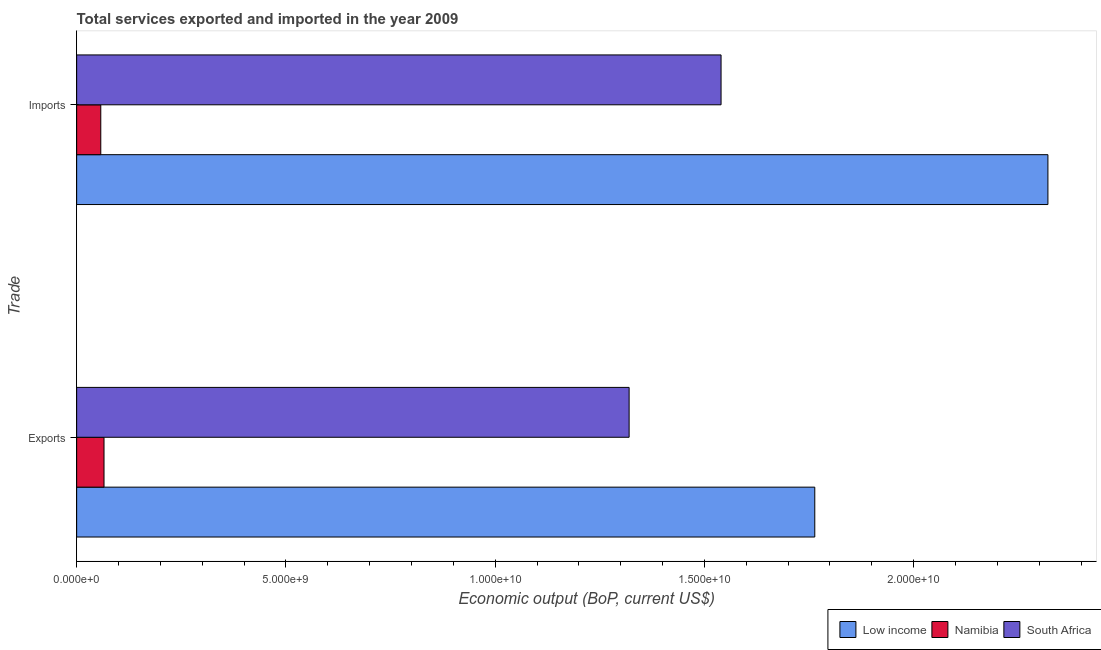How many bars are there on the 1st tick from the top?
Offer a very short reply. 3. How many bars are there on the 2nd tick from the bottom?
Offer a very short reply. 3. What is the label of the 1st group of bars from the top?
Provide a short and direct response. Imports. What is the amount of service exports in Low income?
Give a very brief answer. 1.76e+1. Across all countries, what is the maximum amount of service imports?
Your answer should be compact. 2.32e+1. Across all countries, what is the minimum amount of service exports?
Provide a succinct answer. 6.54e+08. In which country was the amount of service exports minimum?
Offer a terse response. Namibia. What is the total amount of service imports in the graph?
Offer a terse response. 3.92e+1. What is the difference between the amount of service exports in South Africa and that in Namibia?
Give a very brief answer. 1.25e+1. What is the difference between the amount of service exports in Namibia and the amount of service imports in South Africa?
Provide a succinct answer. -1.47e+1. What is the average amount of service exports per country?
Your response must be concise. 1.05e+1. What is the difference between the amount of service exports and amount of service imports in Low income?
Offer a terse response. -5.57e+09. In how many countries, is the amount of service imports greater than 4000000000 US$?
Your answer should be very brief. 2. What is the ratio of the amount of service imports in Namibia to that in Low income?
Provide a short and direct response. 0.02. Is the amount of service exports in Low income less than that in South Africa?
Make the answer very short. No. In how many countries, is the amount of service imports greater than the average amount of service imports taken over all countries?
Your answer should be very brief. 2. What does the 1st bar from the top in Exports represents?
Provide a short and direct response. South Africa. What does the 2nd bar from the bottom in Imports represents?
Offer a very short reply. Namibia. Are the values on the major ticks of X-axis written in scientific E-notation?
Offer a very short reply. Yes. Does the graph contain grids?
Ensure brevity in your answer.  No. Where does the legend appear in the graph?
Give a very brief answer. Bottom right. What is the title of the graph?
Ensure brevity in your answer.  Total services exported and imported in the year 2009. Does "Turkmenistan" appear as one of the legend labels in the graph?
Your answer should be compact. No. What is the label or title of the X-axis?
Your answer should be compact. Economic output (BoP, current US$). What is the label or title of the Y-axis?
Make the answer very short. Trade. What is the Economic output (BoP, current US$) in Low income in Exports?
Your answer should be very brief. 1.76e+1. What is the Economic output (BoP, current US$) in Namibia in Exports?
Keep it short and to the point. 6.54e+08. What is the Economic output (BoP, current US$) in South Africa in Exports?
Ensure brevity in your answer.  1.32e+1. What is the Economic output (BoP, current US$) in Low income in Imports?
Offer a terse response. 2.32e+1. What is the Economic output (BoP, current US$) in Namibia in Imports?
Ensure brevity in your answer.  5.76e+08. What is the Economic output (BoP, current US$) of South Africa in Imports?
Offer a very short reply. 1.54e+1. Across all Trade, what is the maximum Economic output (BoP, current US$) in Low income?
Offer a very short reply. 2.32e+1. Across all Trade, what is the maximum Economic output (BoP, current US$) of Namibia?
Keep it short and to the point. 6.54e+08. Across all Trade, what is the maximum Economic output (BoP, current US$) in South Africa?
Ensure brevity in your answer.  1.54e+1. Across all Trade, what is the minimum Economic output (BoP, current US$) in Low income?
Provide a succinct answer. 1.76e+1. Across all Trade, what is the minimum Economic output (BoP, current US$) of Namibia?
Provide a succinct answer. 5.76e+08. Across all Trade, what is the minimum Economic output (BoP, current US$) of South Africa?
Your response must be concise. 1.32e+1. What is the total Economic output (BoP, current US$) of Low income in the graph?
Your answer should be very brief. 4.08e+1. What is the total Economic output (BoP, current US$) of Namibia in the graph?
Your answer should be very brief. 1.23e+09. What is the total Economic output (BoP, current US$) in South Africa in the graph?
Ensure brevity in your answer.  2.86e+1. What is the difference between the Economic output (BoP, current US$) of Low income in Exports and that in Imports?
Offer a terse response. -5.57e+09. What is the difference between the Economic output (BoP, current US$) in Namibia in Exports and that in Imports?
Your answer should be very brief. 7.74e+07. What is the difference between the Economic output (BoP, current US$) of South Africa in Exports and that in Imports?
Provide a succinct answer. -2.20e+09. What is the difference between the Economic output (BoP, current US$) in Low income in Exports and the Economic output (BoP, current US$) in Namibia in Imports?
Offer a terse response. 1.71e+1. What is the difference between the Economic output (BoP, current US$) of Low income in Exports and the Economic output (BoP, current US$) of South Africa in Imports?
Your answer should be very brief. 2.24e+09. What is the difference between the Economic output (BoP, current US$) of Namibia in Exports and the Economic output (BoP, current US$) of South Africa in Imports?
Make the answer very short. -1.47e+1. What is the average Economic output (BoP, current US$) in Low income per Trade?
Offer a very short reply. 2.04e+1. What is the average Economic output (BoP, current US$) of Namibia per Trade?
Provide a short and direct response. 6.15e+08. What is the average Economic output (BoP, current US$) in South Africa per Trade?
Make the answer very short. 1.43e+1. What is the difference between the Economic output (BoP, current US$) of Low income and Economic output (BoP, current US$) of Namibia in Exports?
Make the answer very short. 1.70e+1. What is the difference between the Economic output (BoP, current US$) of Low income and Economic output (BoP, current US$) of South Africa in Exports?
Provide a short and direct response. 4.44e+09. What is the difference between the Economic output (BoP, current US$) of Namibia and Economic output (BoP, current US$) of South Africa in Exports?
Ensure brevity in your answer.  -1.25e+1. What is the difference between the Economic output (BoP, current US$) of Low income and Economic output (BoP, current US$) of Namibia in Imports?
Keep it short and to the point. 2.26e+1. What is the difference between the Economic output (BoP, current US$) of Low income and Economic output (BoP, current US$) of South Africa in Imports?
Ensure brevity in your answer.  7.81e+09. What is the difference between the Economic output (BoP, current US$) of Namibia and Economic output (BoP, current US$) of South Africa in Imports?
Make the answer very short. -1.48e+1. What is the ratio of the Economic output (BoP, current US$) in Low income in Exports to that in Imports?
Keep it short and to the point. 0.76. What is the ratio of the Economic output (BoP, current US$) of Namibia in Exports to that in Imports?
Your answer should be very brief. 1.13. What is the ratio of the Economic output (BoP, current US$) in South Africa in Exports to that in Imports?
Ensure brevity in your answer.  0.86. What is the difference between the highest and the second highest Economic output (BoP, current US$) in Low income?
Offer a very short reply. 5.57e+09. What is the difference between the highest and the second highest Economic output (BoP, current US$) of Namibia?
Offer a terse response. 7.74e+07. What is the difference between the highest and the second highest Economic output (BoP, current US$) of South Africa?
Provide a succinct answer. 2.20e+09. What is the difference between the highest and the lowest Economic output (BoP, current US$) in Low income?
Your response must be concise. 5.57e+09. What is the difference between the highest and the lowest Economic output (BoP, current US$) of Namibia?
Ensure brevity in your answer.  7.74e+07. What is the difference between the highest and the lowest Economic output (BoP, current US$) in South Africa?
Provide a succinct answer. 2.20e+09. 